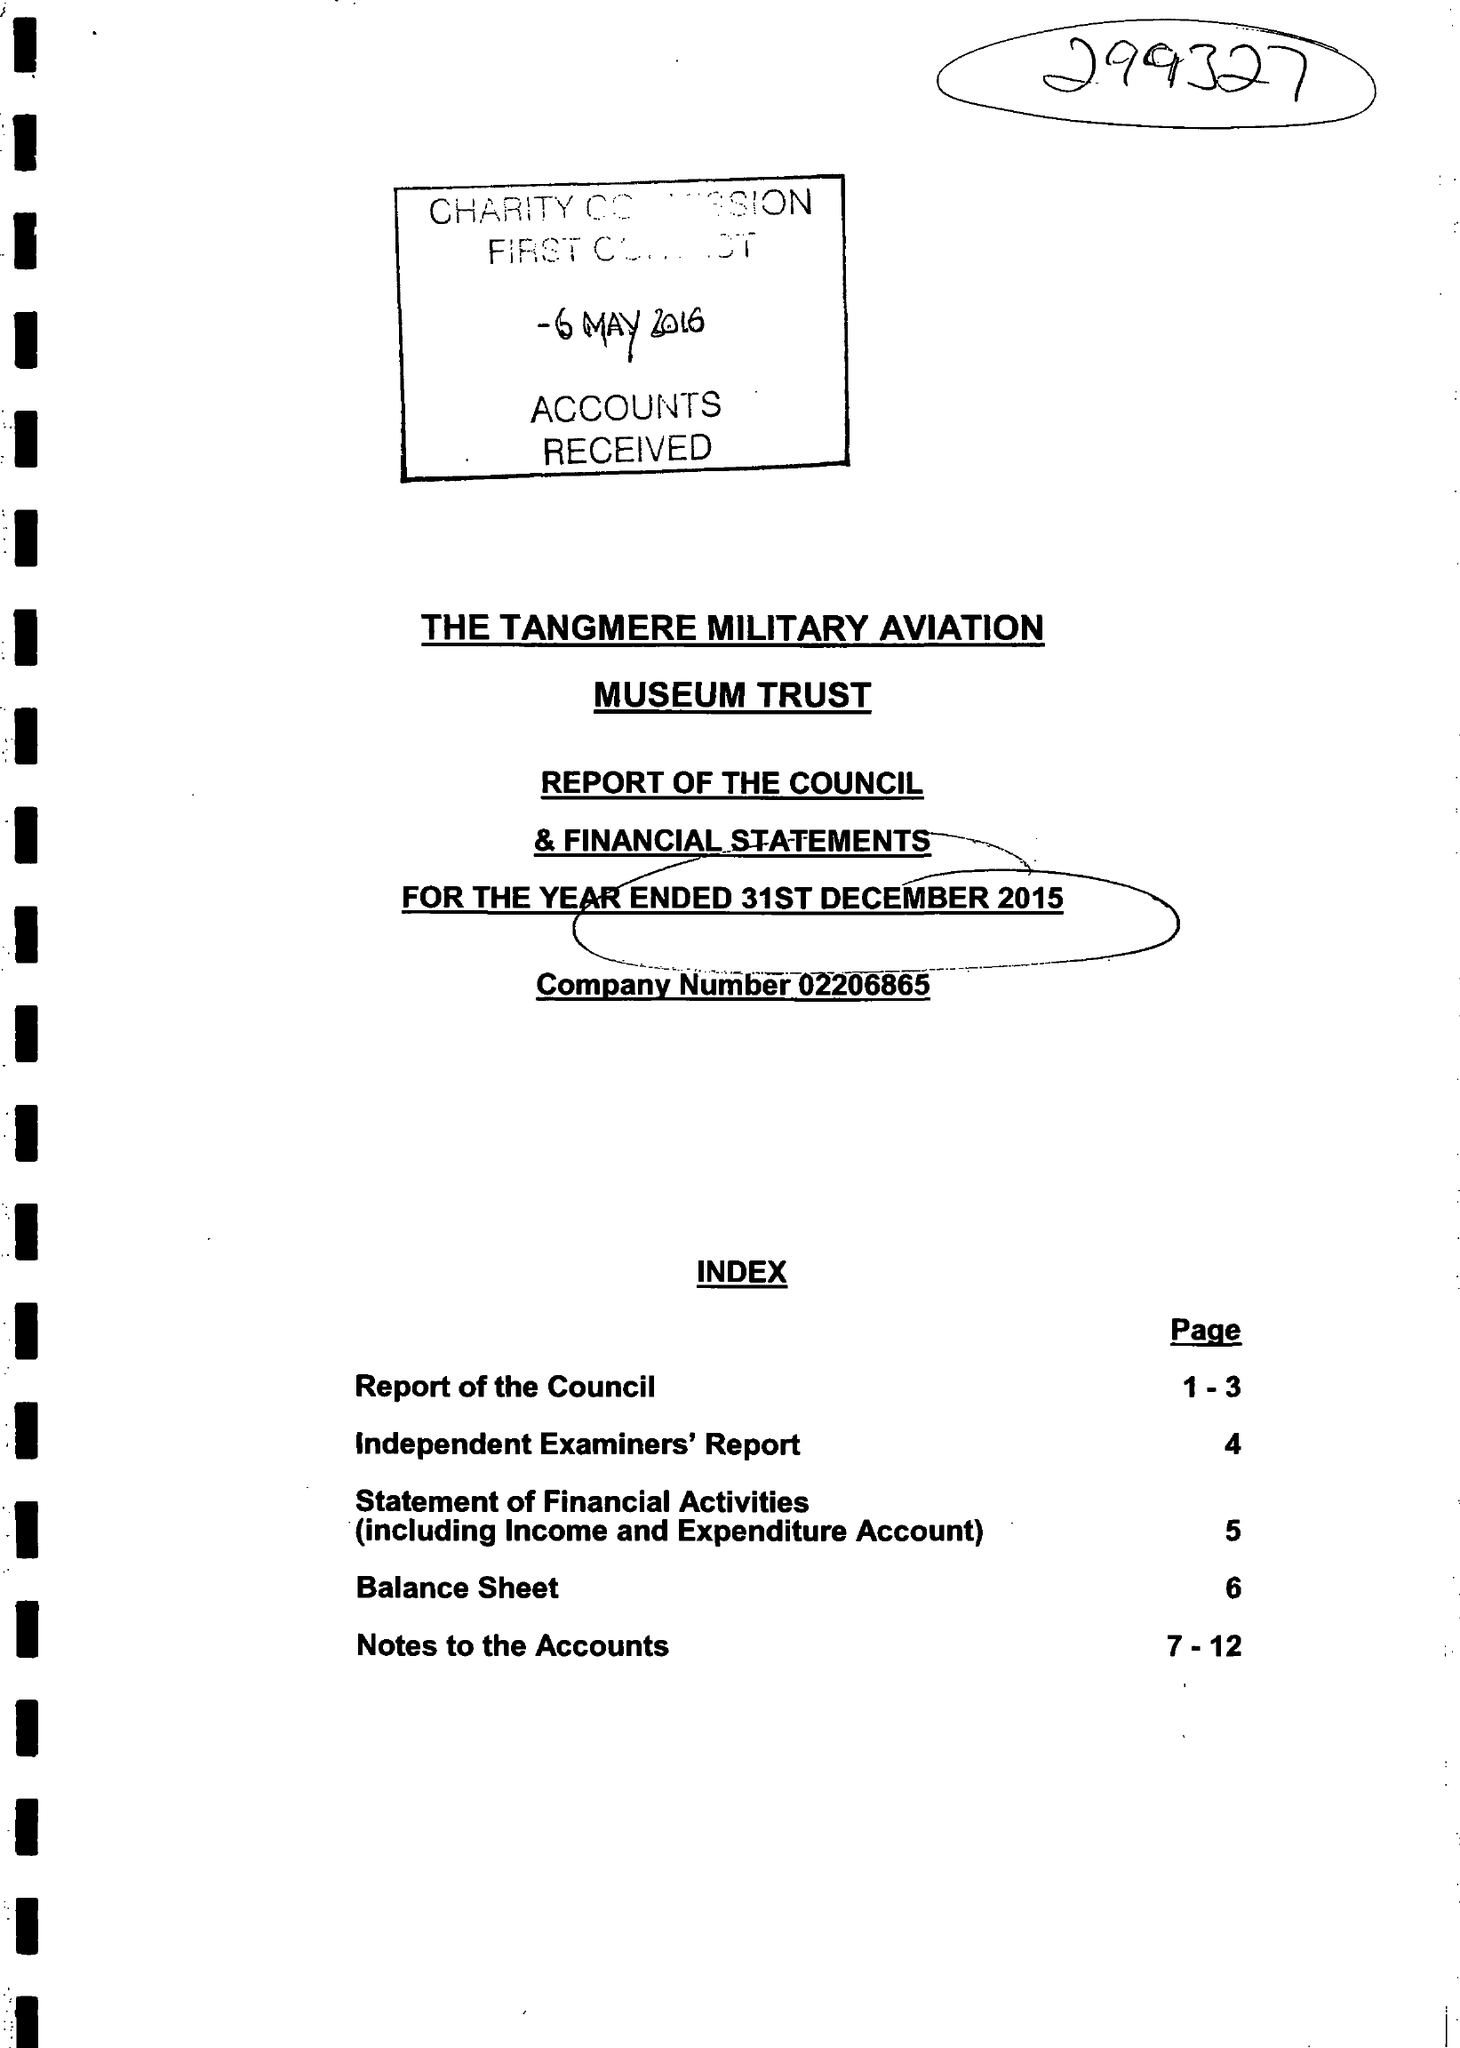What is the value for the spending_annually_in_british_pounds?
Answer the question using a single word or phrase. 206302.00 